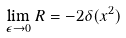Convert formula to latex. <formula><loc_0><loc_0><loc_500><loc_500>\lim _ { \epsilon \to 0 } R = - 2 \delta ( x ^ { 2 } )</formula> 